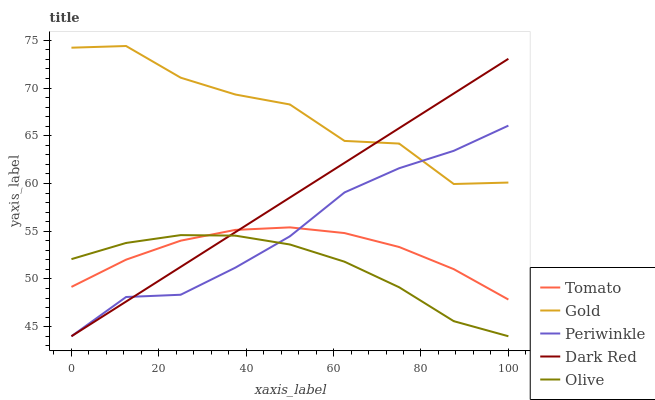Does Olive have the minimum area under the curve?
Answer yes or no. Yes. Does Gold have the maximum area under the curve?
Answer yes or no. Yes. Does Dark Red have the minimum area under the curve?
Answer yes or no. No. Does Dark Red have the maximum area under the curve?
Answer yes or no. No. Is Dark Red the smoothest?
Answer yes or no. Yes. Is Gold the roughest?
Answer yes or no. Yes. Is Periwinkle the smoothest?
Answer yes or no. No. Is Periwinkle the roughest?
Answer yes or no. No. Does Dark Red have the lowest value?
Answer yes or no. Yes. Does Gold have the lowest value?
Answer yes or no. No. Does Gold have the highest value?
Answer yes or no. Yes. Does Dark Red have the highest value?
Answer yes or no. No. Is Tomato less than Gold?
Answer yes or no. Yes. Is Gold greater than Olive?
Answer yes or no. Yes. Does Olive intersect Tomato?
Answer yes or no. Yes. Is Olive less than Tomato?
Answer yes or no. No. Is Olive greater than Tomato?
Answer yes or no. No. Does Tomato intersect Gold?
Answer yes or no. No. 